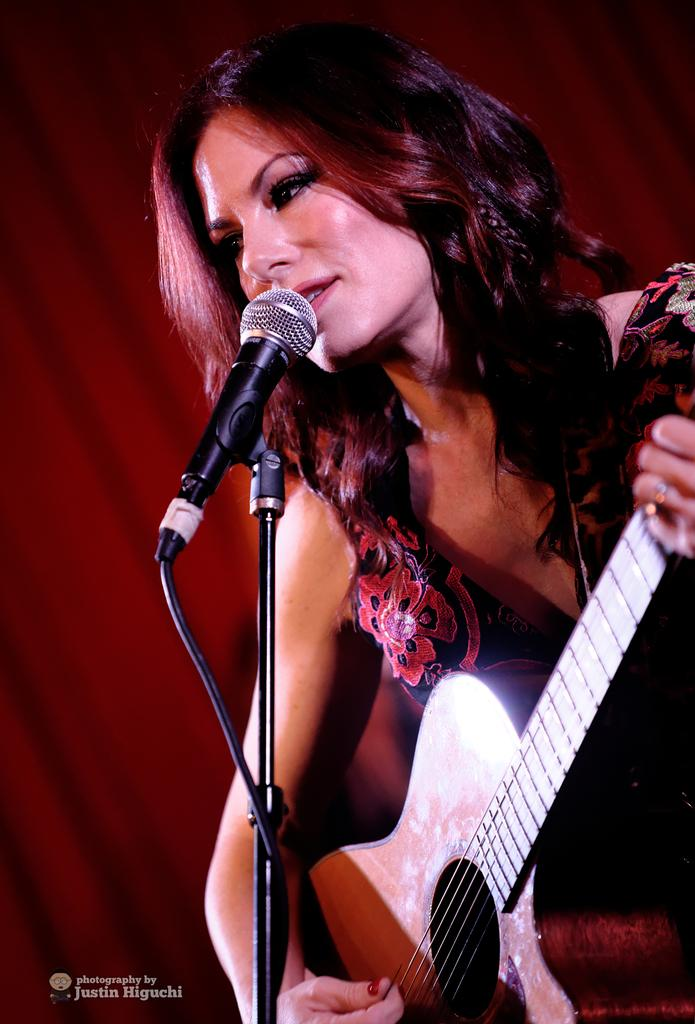Who is the main subject in the image? There is a woman in the image. What is the woman holding in the image? The woman is holding a guitar. What object is in front of the woman? There is a microphone in front of the woman. What type of toys can be seen in the image? There are no toys present in the image. What other musical instruments can be seen in the image besides the guitar? There are no other musical instruments visible in the image. 